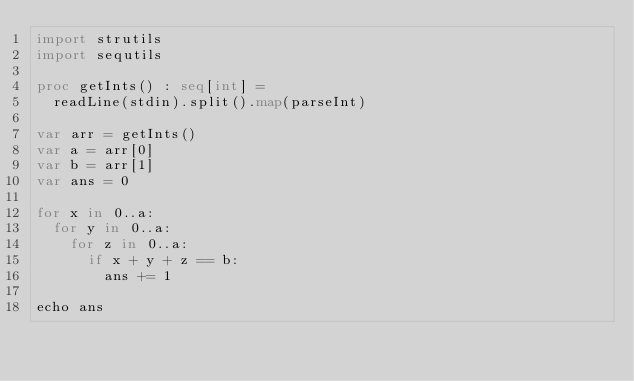Convert code to text. <code><loc_0><loc_0><loc_500><loc_500><_Nim_>import strutils
import sequtils
 
proc getInts() : seq[int] = 
  readLine(stdin).split().map(parseInt)
    
var arr = getInts()
var a = arr[0]
var b = arr[1]
var ans = 0
 
for x in 0..a:
  for y in 0..a:
    for z in 0..a:
      if x + y + z == b:
        ans += 1
 
echo ans </code> 